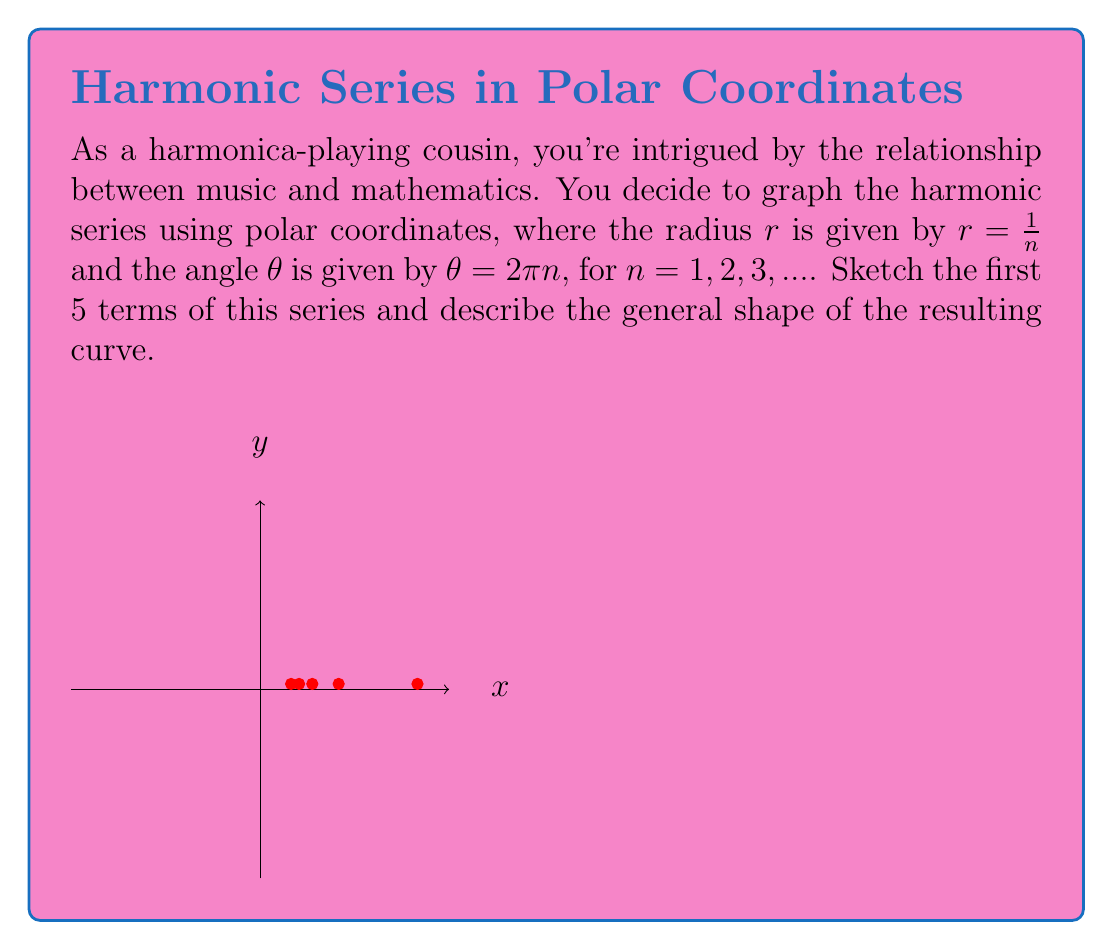Give your solution to this math problem. Let's approach this step-by-step:

1) The polar equation for the harmonic series is given by:
   $r = \frac{1}{n}$ and $\theta = 2\pi n$, where $n = 1, 2, 3, ...$

2) Let's calculate the first 5 terms:

   For $n = 1$: $r = 1$, $\theta = 2\pi$
   For $n = 2$: $r = \frac{1}{2}$, $\theta = 4\pi$
   For $n = 3$: $r = \frac{1}{3}$, $\theta = 6\pi$
   For $n = 4$: $r = \frac{1}{4}$, $\theta = 8\pi$
   For $n = 5$: $r = \frac{1}{5}$, $\theta = 10\pi$

3) The first point $(n = 1)$ will be a circle with radius 1, as $r = 1$ and $\theta = 2\pi$.

4) For subsequent points, the radius decreases as $n$ increases, while the angle increases.

5) This results in a spiral that starts at $(1,0)$ and winds inward towards the origin.

6) As $n$ approaches infinity, $r$ approaches 0, so the spiral will continue to wind infinitely many times, getting closer and closer to the origin without ever reaching it.

7) The general shape of the curve is an inward spiral, reminiscent of the shape of a nautilus shell.
Answer: An inward spiral that winds infinitely towards the origin 